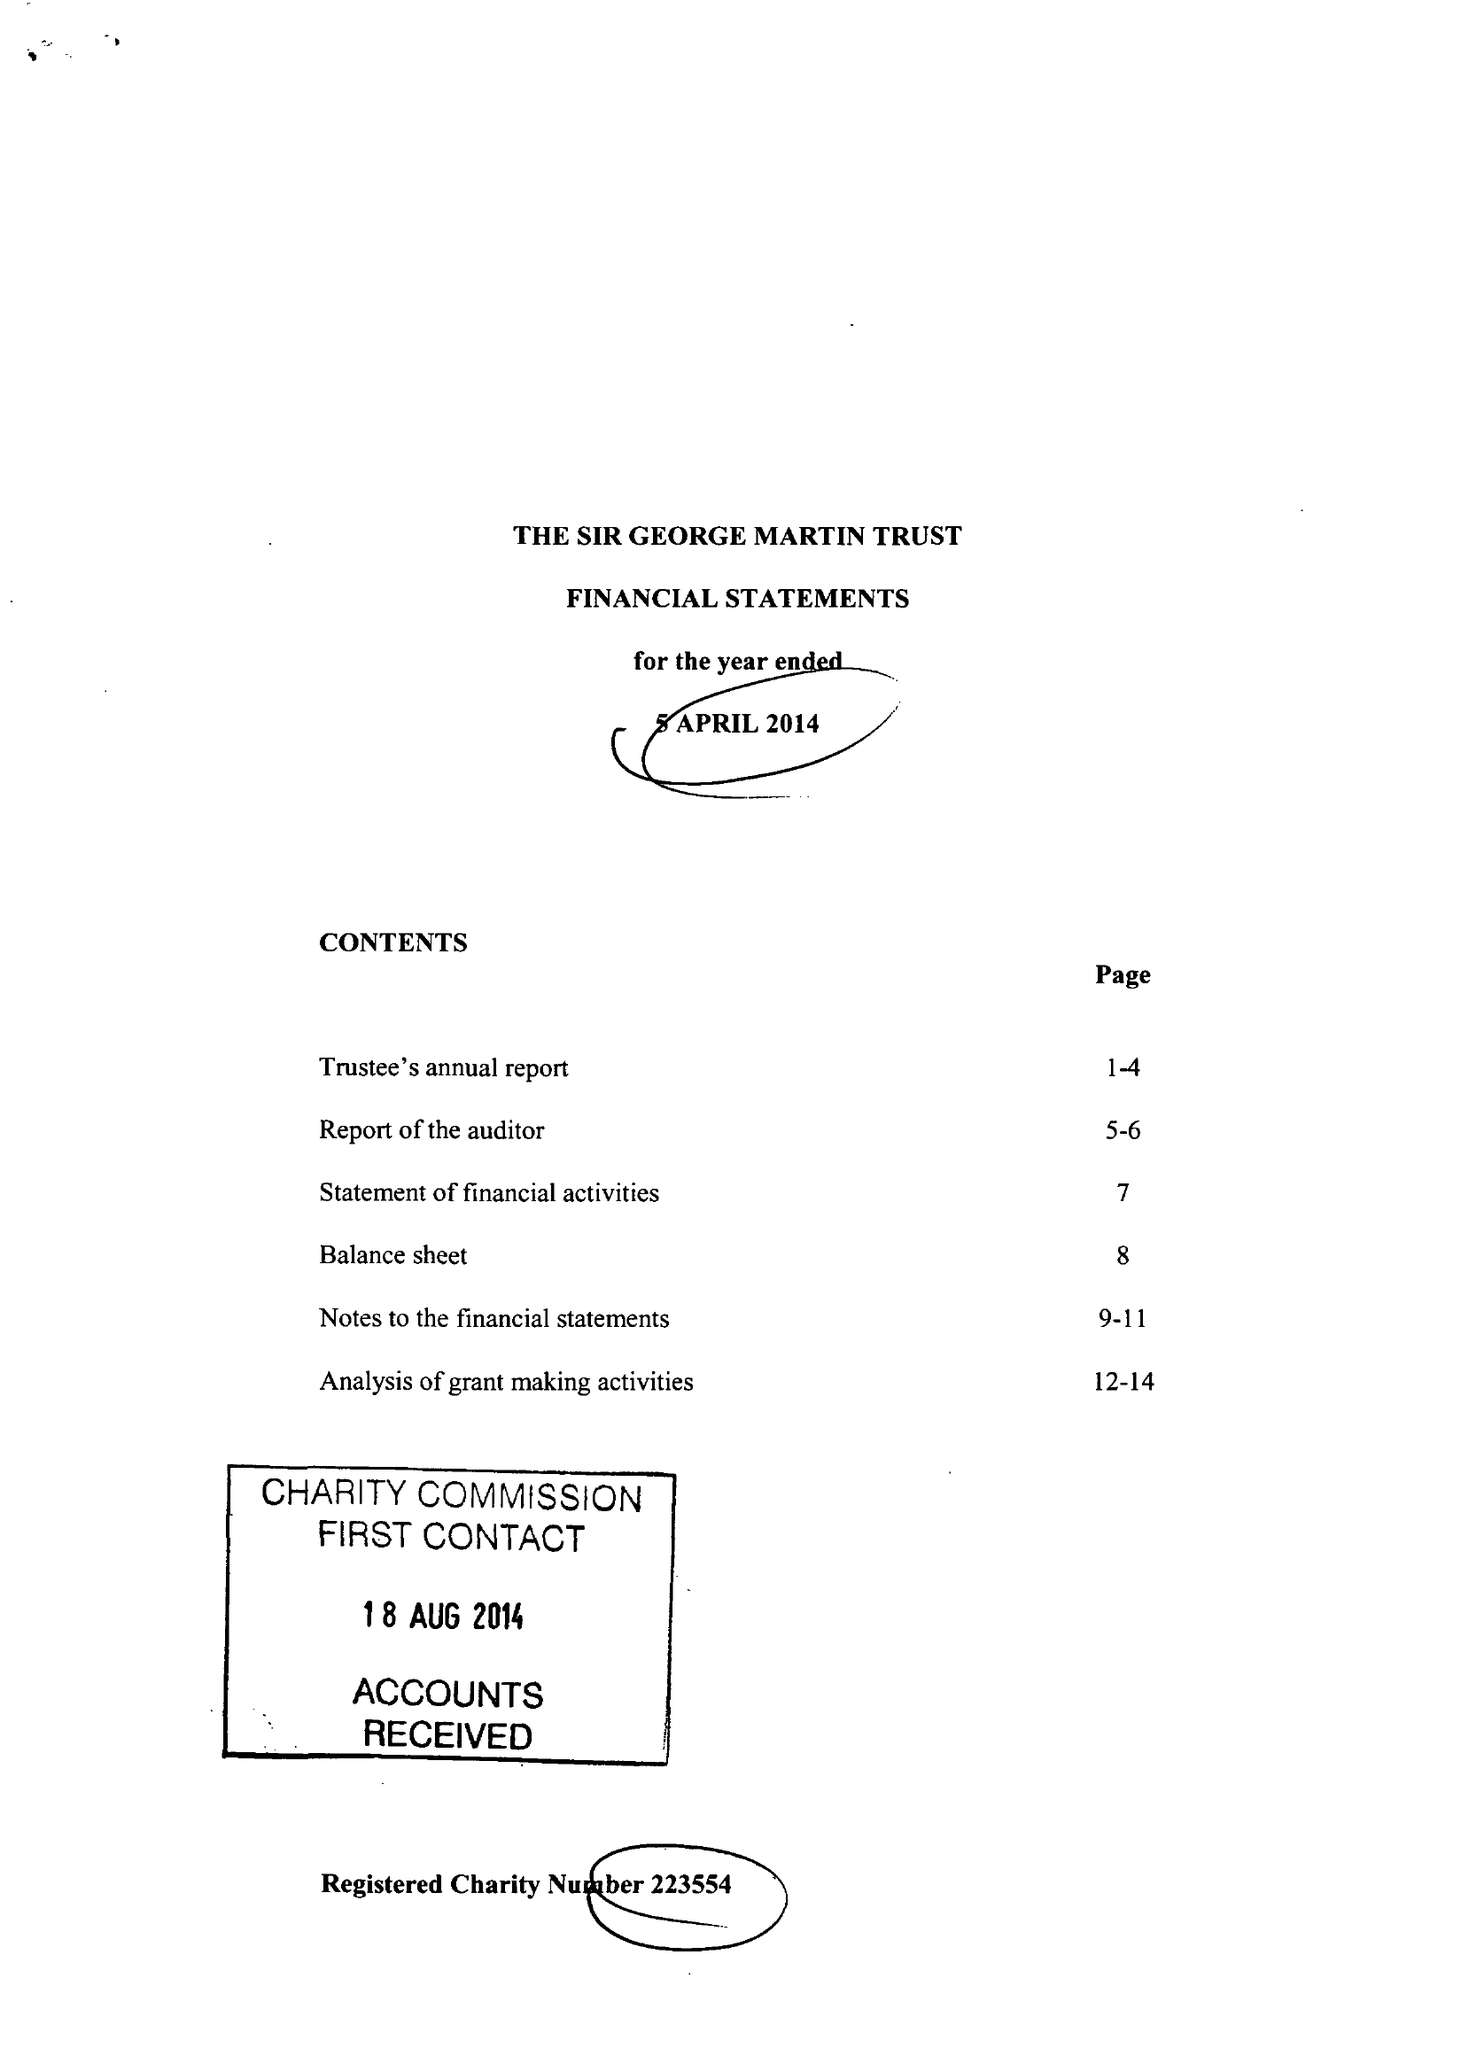What is the value for the spending_annually_in_british_pounds?
Answer the question using a single word or phrase. 253371.00 